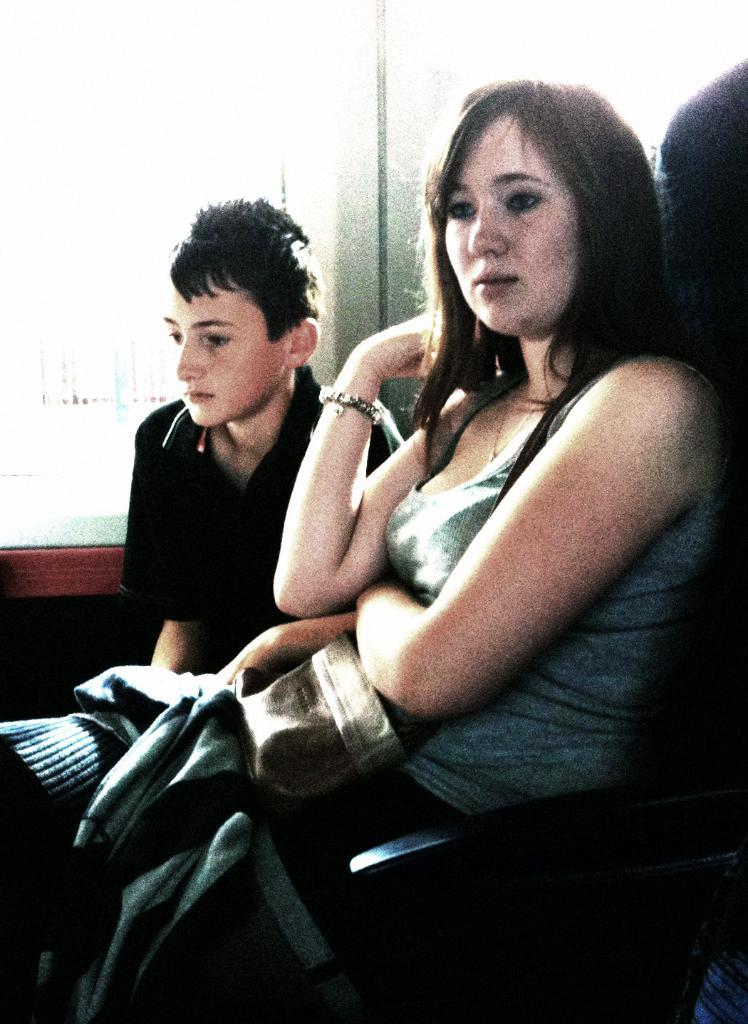What is the woman in the image doing? The woman is sitting on a chair in the image. What is on the woman's lap? The woman has a cloth on her lap. Who is beside the woman? There is a person wearing a black top beside the woman. What can be seen behind the woman and the person in the image? There is a window visible behind them. What type of industry can be seen through the window in the image? There is no industry visible through the window in the image. Is there a stranger in the image? The provided facts do not mention a stranger, so it cannot be determined if there is one in the image. 